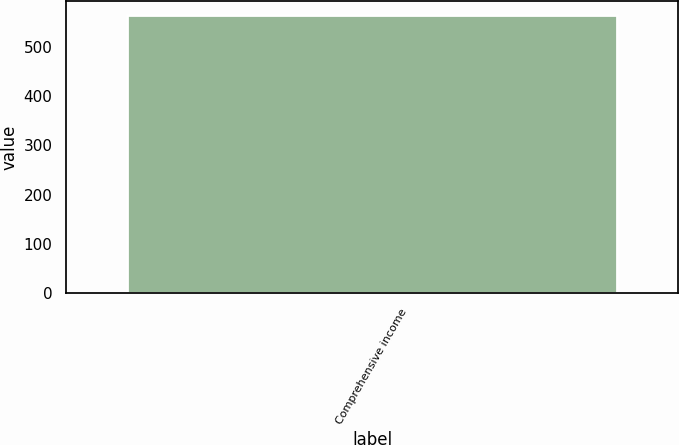Convert chart. <chart><loc_0><loc_0><loc_500><loc_500><bar_chart><fcel>Comprehensive income<nl><fcel>565.1<nl></chart> 